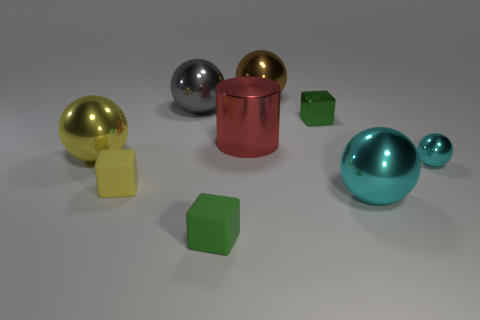Subtract all gray balls. How many balls are left? 4 Subtract all brown metal balls. How many balls are left? 4 Subtract 1 balls. How many balls are left? 4 Subtract all red spheres. Subtract all green cylinders. How many spheres are left? 5 Add 1 yellow things. How many objects exist? 10 Subtract all spheres. How many objects are left? 4 Add 2 large green metallic balls. How many large green metallic balls exist? 2 Subtract 0 red blocks. How many objects are left? 9 Subtract all big cyan balls. Subtract all tiny purple metal blocks. How many objects are left? 8 Add 4 large red objects. How many large red objects are left? 5 